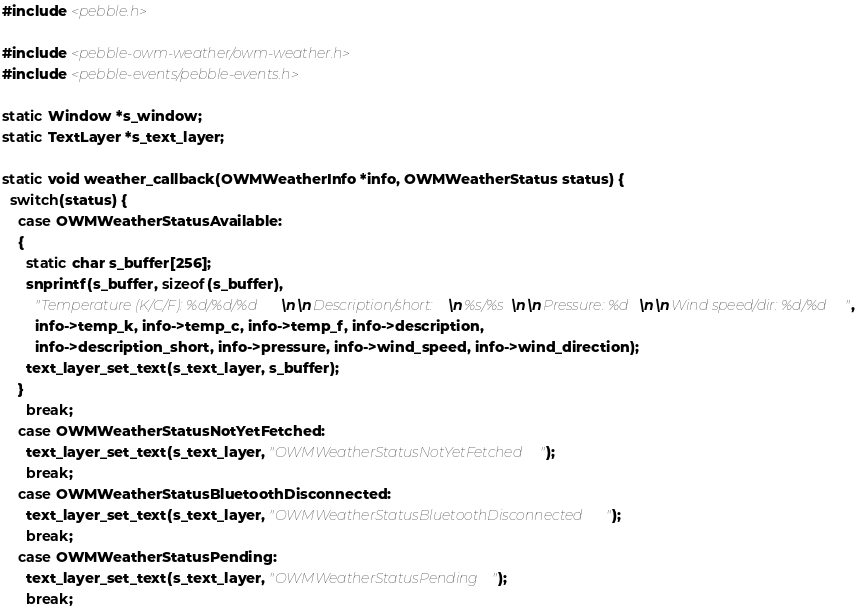<code> <loc_0><loc_0><loc_500><loc_500><_C_>#include <pebble.h>

#include <pebble-owm-weather/owm-weather.h>
#include <pebble-events/pebble-events.h>

static Window *s_window;
static TextLayer *s_text_layer;

static void weather_callback(OWMWeatherInfo *info, OWMWeatherStatus status) {
  switch(status) {
    case OWMWeatherStatusAvailable:
    {
      static char s_buffer[256];
      snprintf(s_buffer, sizeof(s_buffer),
        "Temperature (K/C/F): %d/%d/%d\n\nDescription/short:\n%s/%s\n\nPressure: %d\n\nWind speed/dir: %d/%d",
        info->temp_k, info->temp_c, info->temp_f, info->description,
        info->description_short, info->pressure, info->wind_speed, info->wind_direction);
      text_layer_set_text(s_text_layer, s_buffer);
    }
      break;
    case OWMWeatherStatusNotYetFetched:
      text_layer_set_text(s_text_layer, "OWMWeatherStatusNotYetFetched");
      break;
    case OWMWeatherStatusBluetoothDisconnected:
      text_layer_set_text(s_text_layer, "OWMWeatherStatusBluetoothDisconnected");
      break;
    case OWMWeatherStatusPending:
      text_layer_set_text(s_text_layer, "OWMWeatherStatusPending");
      break;</code> 